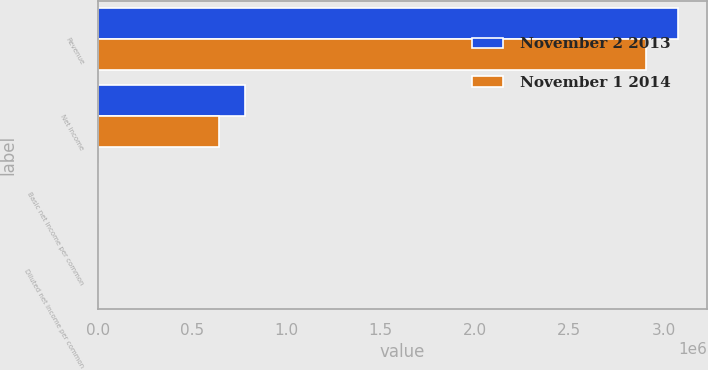Convert chart to OTSL. <chart><loc_0><loc_0><loc_500><loc_500><stacked_bar_chart><ecel><fcel>Revenue<fcel>Net income<fcel>Basic net income per common<fcel>Diluted net income per common<nl><fcel>November 2 2013<fcel>3.07547e+06<fcel>778049<fcel>2.48<fcel>2.44<nl><fcel>November 1 2014<fcel>2.9075e+06<fcel>641217<fcel>2.08<fcel>2.04<nl></chart> 